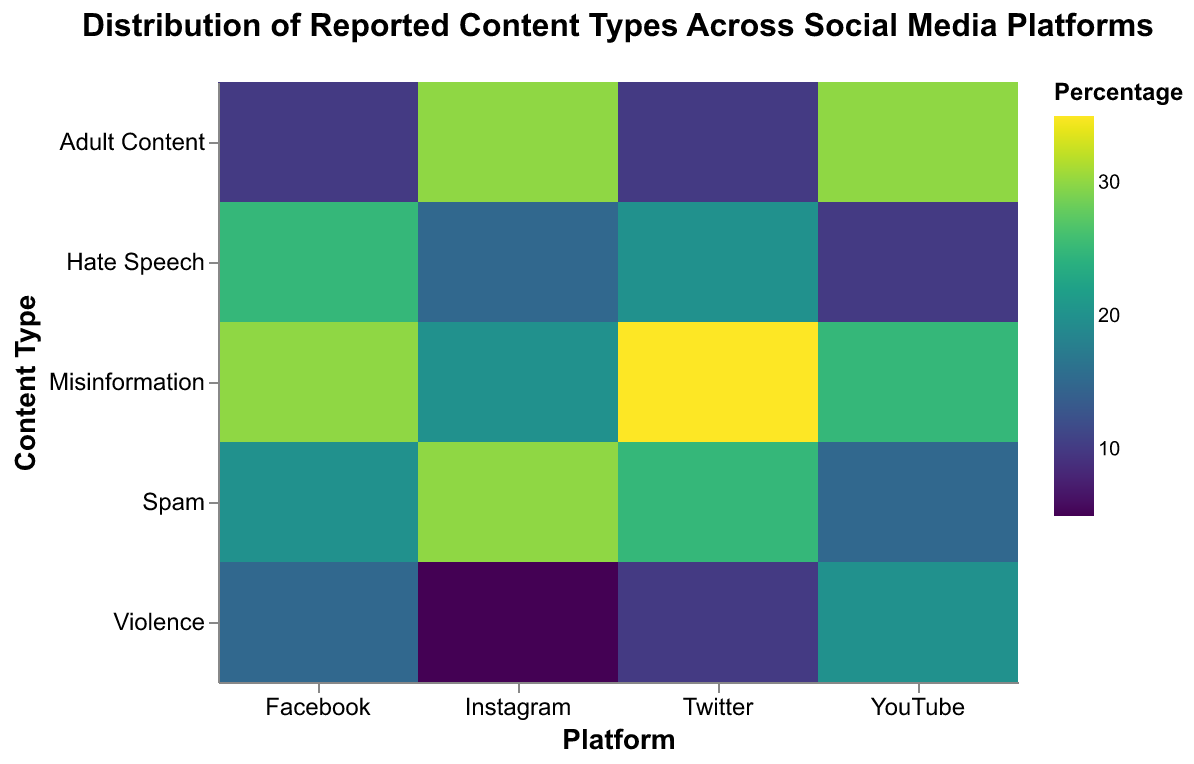What's the title of the plot? The title is displayed at the top of the figure and reads "Distribution of Reported Content Types Across Social Media Platforms".
Answer: Distribution of Reported Content Types Across Social Media Platforms Which platform has the highest percentage of 'Spam' content? Identify the percentage values for 'Spam' content across all platforms. Instagram has the highest percentage at 30%.
Answer: Instagram Which content type has the lowest percentage reported on Instagram? Look at the percentages for all content types on Instagram and identify the lowest value. 'Violence' has the lowest percentage at 5%.
Answer: Violence What is the percentage difference between 'Misinformation' on Facebook and Twitter? Subtract the percentage of 'Misinformation' on Facebook (30%) from that on Twitter (35%) to get the difference.
Answer: 5% Which platform reports the highest percentage of 'Hate Speech'? Compare the 'Hate Speech' percentages across all platforms: Facebook (25%), Twitter (20%), Instagram (15%), and YouTube (10%). The highest percentage is on Facebook.
Answer: Facebook On which platform is 'Adult Content' reported most frequently? Compare the 'Adult Content' percentages across all platforms: Facebook (10%), Twitter (10%), Instagram (30%), and YouTube (30%). The highest percentage is on both Instagram and YouTube.
Answer: Instagram and YouTube How does the percentage of 'Violence' reported on YouTube compare to Facebook? The percentage of 'Violence' on YouTube (20%) is higher than that on Facebook (15%).
Answer: Higher What is the average percentage of 'Spam' content across all platforms? Sum the percentages of 'Spam' content across all platforms (20% + 25% + 30% + 15%) and divide by the number of platforms (4). The average is (20 + 25 + 30 + 15) / 4 = 22.5%.
Answer: 22.5% If we combine the percentages of 'Violence' and 'Adult Content' on Twitter, what is the result? Add the percentages of 'Violence' (10%) and 'Adult Content' (10%) on Twitter. The result is 10% + 10% = 20%.
Answer: 20% Compare the percentage of 'Spam' on Facebook to that on Instagram and find the difference. Subtract the percentage of 'Spam' on Facebook (20%) from that on Instagram (30%). The difference is 30% - 20% = 10%.
Answer: 10% 